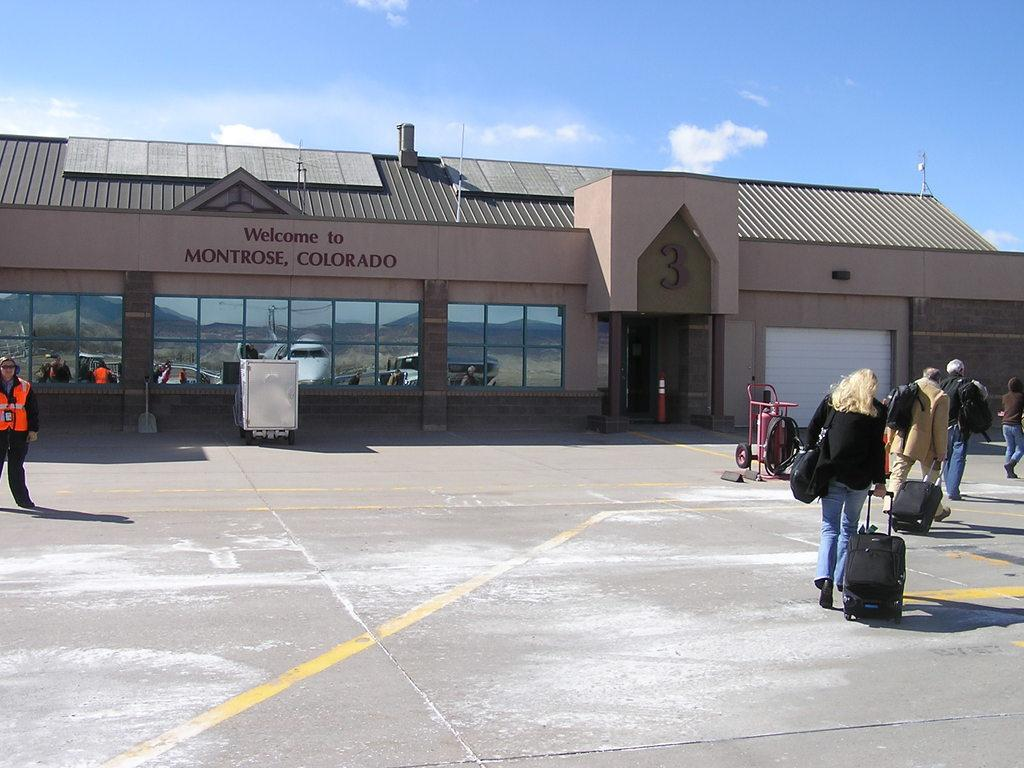What structure can be seen in the image? There is a building in the image. What are the people in the image doing? The people are walking in the image. What are the people carrying while walking? The people are carrying luggage. Where are the people walking in relation to the building? The people are walking on a pavement in front of the building. Can you tell me how many chickens are walking alongside the people in the image? There are no chickens present in the image; it only features people walking with luggage in front of a building. 